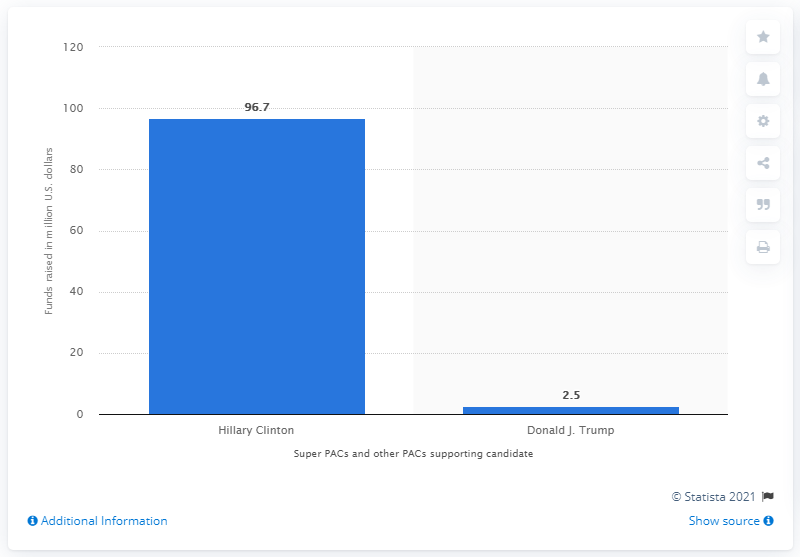Draw attention to some important aspects in this diagram. Hillary Clinton received a significant amount of support from super PACs, raising 96.7 million dollars in total. The result of dividing the large bar value by the small one is 38.68... PACs, which are political action committees, supported Hillary Clinton. What is the result of multiplying the sum of two funds by itself? 9.96... 